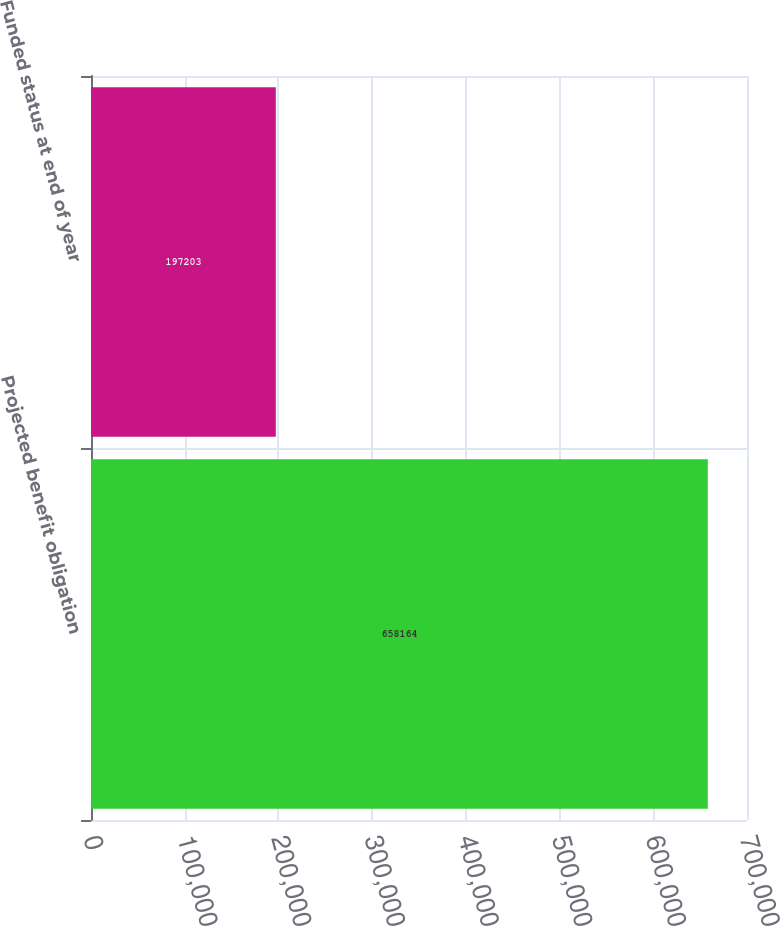<chart> <loc_0><loc_0><loc_500><loc_500><bar_chart><fcel>Projected benefit obligation<fcel>Funded status at end of year<nl><fcel>658164<fcel>197203<nl></chart> 